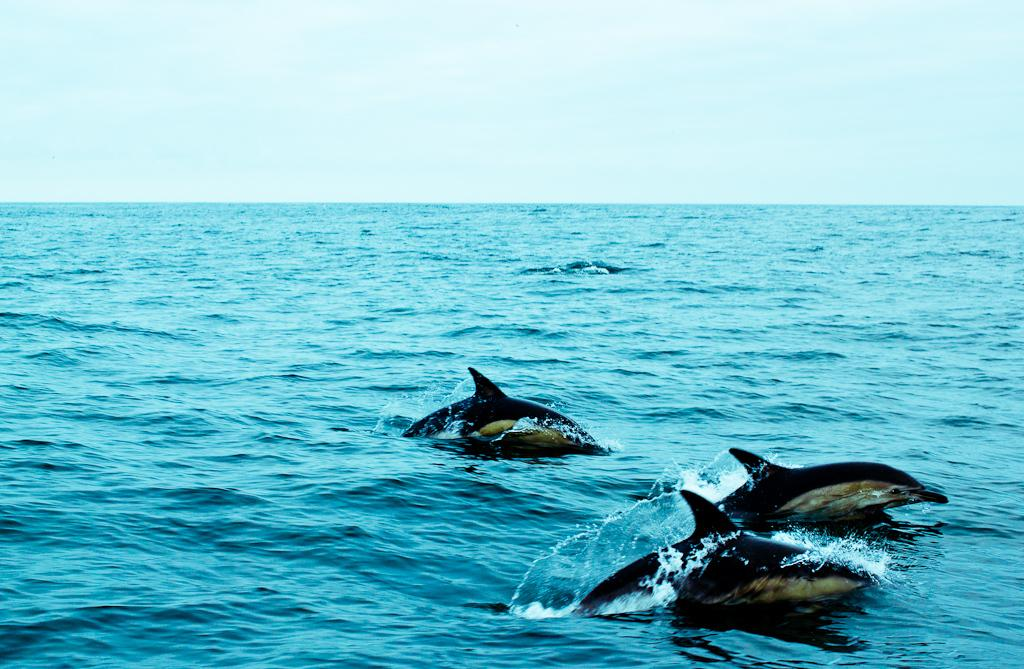What animals can be seen in the water in the image? There are dolphins in the water in the image. What is the condition of the sky in the image? The sky is cloudy in the image. What type of polish is being applied to the notebook in the image? There is no notebook or polish present in the image; it features dolphins in the water and a cloudy sky. 